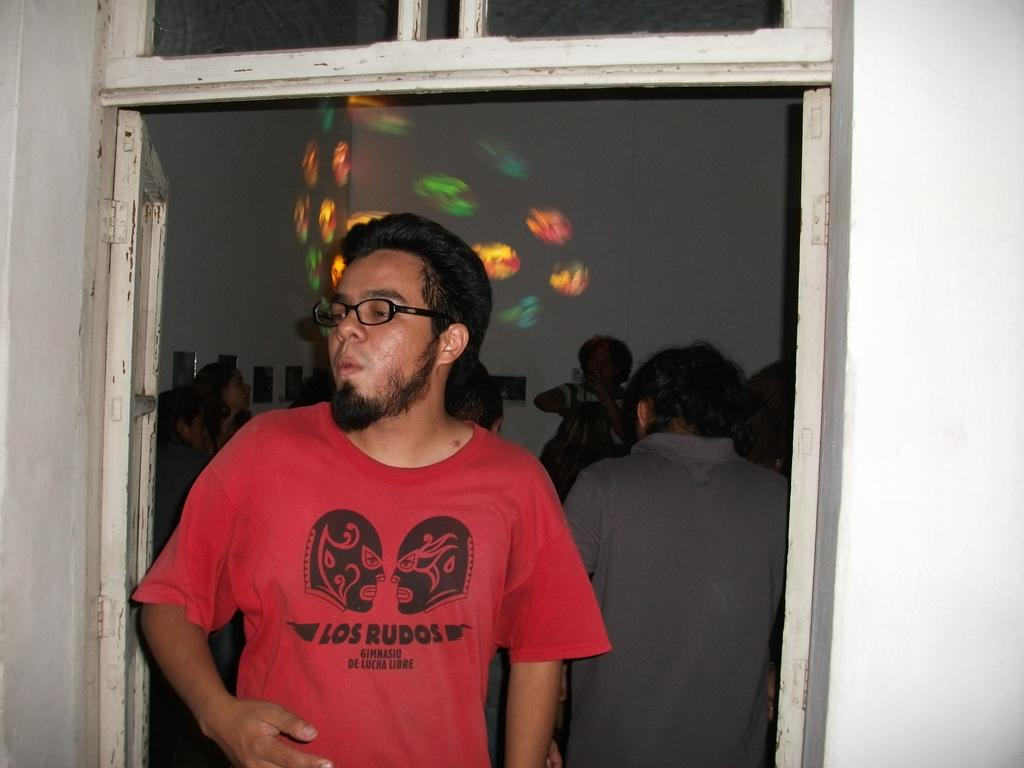What is the main subject in the foreground of the image? There is a man standing in the foreground of the image. What can be seen in the background of the image? There are people, frames, windows, and a door in the background of the image. Can you describe the setting of the image? The image appears to be set in a room with a door and windows in the background. What type of toad is sitting on the man's shoulder in the image? There is no toad present in the image; the man is standing alone in the foreground. 